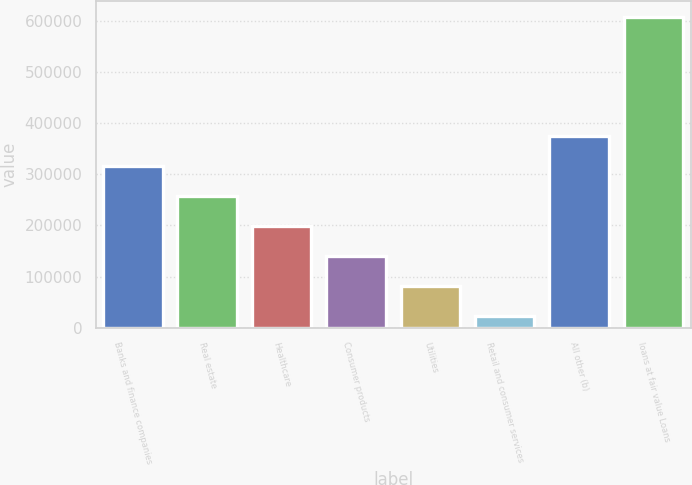<chart> <loc_0><loc_0><loc_500><loc_500><bar_chart><fcel>Banks and finance companies<fcel>Real estate<fcel>Healthcare<fcel>Consumer products<fcel>Utilities<fcel>Retail and consumer services<fcel>All other (b)<fcel>loans at fair value Loans<nl><fcel>315191<fcel>256577<fcel>197963<fcel>139350<fcel>80735.8<fcel>22122<fcel>373805<fcel>608260<nl></chart> 